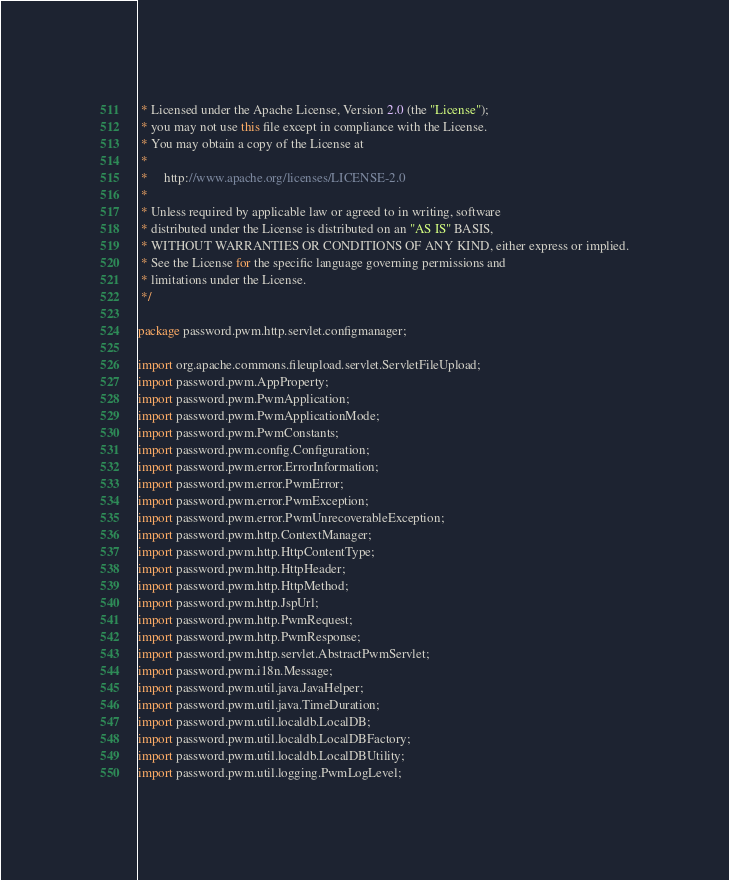<code> <loc_0><loc_0><loc_500><loc_500><_Java_> * Licensed under the Apache License, Version 2.0 (the "License");
 * you may not use this file except in compliance with the License.
 * You may obtain a copy of the License at
 *
 *     http://www.apache.org/licenses/LICENSE-2.0
 *
 * Unless required by applicable law or agreed to in writing, software
 * distributed under the License is distributed on an "AS IS" BASIS,
 * WITHOUT WARRANTIES OR CONDITIONS OF ANY KIND, either express or implied.
 * See the License for the specific language governing permissions and
 * limitations under the License.
 */

package password.pwm.http.servlet.configmanager;

import org.apache.commons.fileupload.servlet.ServletFileUpload;
import password.pwm.AppProperty;
import password.pwm.PwmApplication;
import password.pwm.PwmApplicationMode;
import password.pwm.PwmConstants;
import password.pwm.config.Configuration;
import password.pwm.error.ErrorInformation;
import password.pwm.error.PwmError;
import password.pwm.error.PwmException;
import password.pwm.error.PwmUnrecoverableException;
import password.pwm.http.ContextManager;
import password.pwm.http.HttpContentType;
import password.pwm.http.HttpHeader;
import password.pwm.http.HttpMethod;
import password.pwm.http.JspUrl;
import password.pwm.http.PwmRequest;
import password.pwm.http.PwmResponse;
import password.pwm.http.servlet.AbstractPwmServlet;
import password.pwm.i18n.Message;
import password.pwm.util.java.JavaHelper;
import password.pwm.util.java.TimeDuration;
import password.pwm.util.localdb.LocalDB;
import password.pwm.util.localdb.LocalDBFactory;
import password.pwm.util.localdb.LocalDBUtility;
import password.pwm.util.logging.PwmLogLevel;</code> 